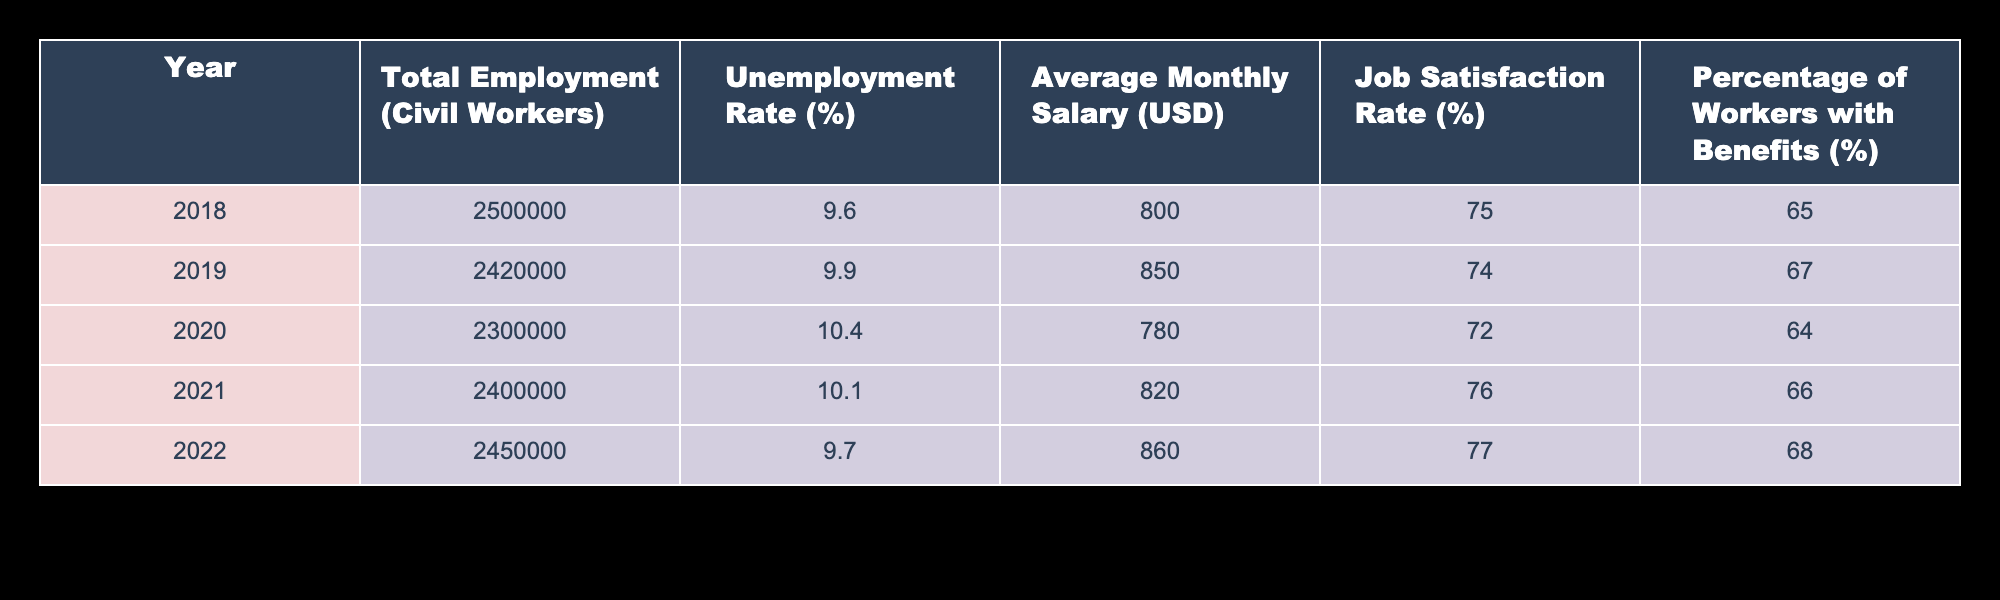What was the total employment of civil workers in Argentina in 2022? The table shows that in 2022, the total employment of civil workers in Argentina is explicitly listed as 2,450,000.
Answer: 2,450,000 What was the average monthly salary for civil workers in 2018? According to the table, the average monthly salary for civil workers in 2018 is specified as 800 USD.
Answer: 800 USD Which year experienced the highest unemployment rate among civil workers? By examining the unemployment rate column for each year, it is clear that the highest rate is 10.4%, which occurred in 2020.
Answer: 2020 What is the average unemployment rate for civil workers over these five years? To find the average, add the unemployment rates from each year: 9.6 + 9.9 + 10.4 + 10.1 + 9.7 = 49.7. Then divide by 5 to get the average: 49.7 / 5 = 9.94%.
Answer: 9.94% Is the job satisfaction rate for civil workers higher in 2022 than in 2018? The job satisfaction rates are listed as 77% for 2022 and 75% for 2018, which means that the rate in 2022 is indeed higher.
Answer: Yes Did the percentage of workers with benefits increase from 2018 to 2022? The percentage of workers with benefits in 2018 is 65%, while in 2022 it is 68%. Thus, the percentage increased over this period.
Answer: Yes What is the difference in average monthly salary between 2019 and 2021? The average monthly salary in 2019 is 850 USD, and in 2021 it is 820 USD. The difference can be calculated as 850 - 820 = 30 USD.
Answer: 30 USD Which year saw a decrease in both total employment and average monthly salary compared to the previous year? By reviewing the table, the total employment decreases from 2,420,000 in 2019 to 2,300,000 in 2020 and the average salary from 850 USD to 780 USD, showing a decrease in both metrics for the year 2020.
Answer: 2020 What was the trend in job satisfaction from 2018 to 2022? Looking at the job satisfaction rates from 2018 to 2022, they increased from 75% to 77%. Therefore, the trend is an increase over the years.
Answer: Increase 